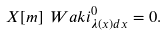<formula> <loc_0><loc_0><loc_500><loc_500>X [ m ] \ W a k i ^ { 0 } _ { \lambda ( x ) d x } = 0 .</formula> 